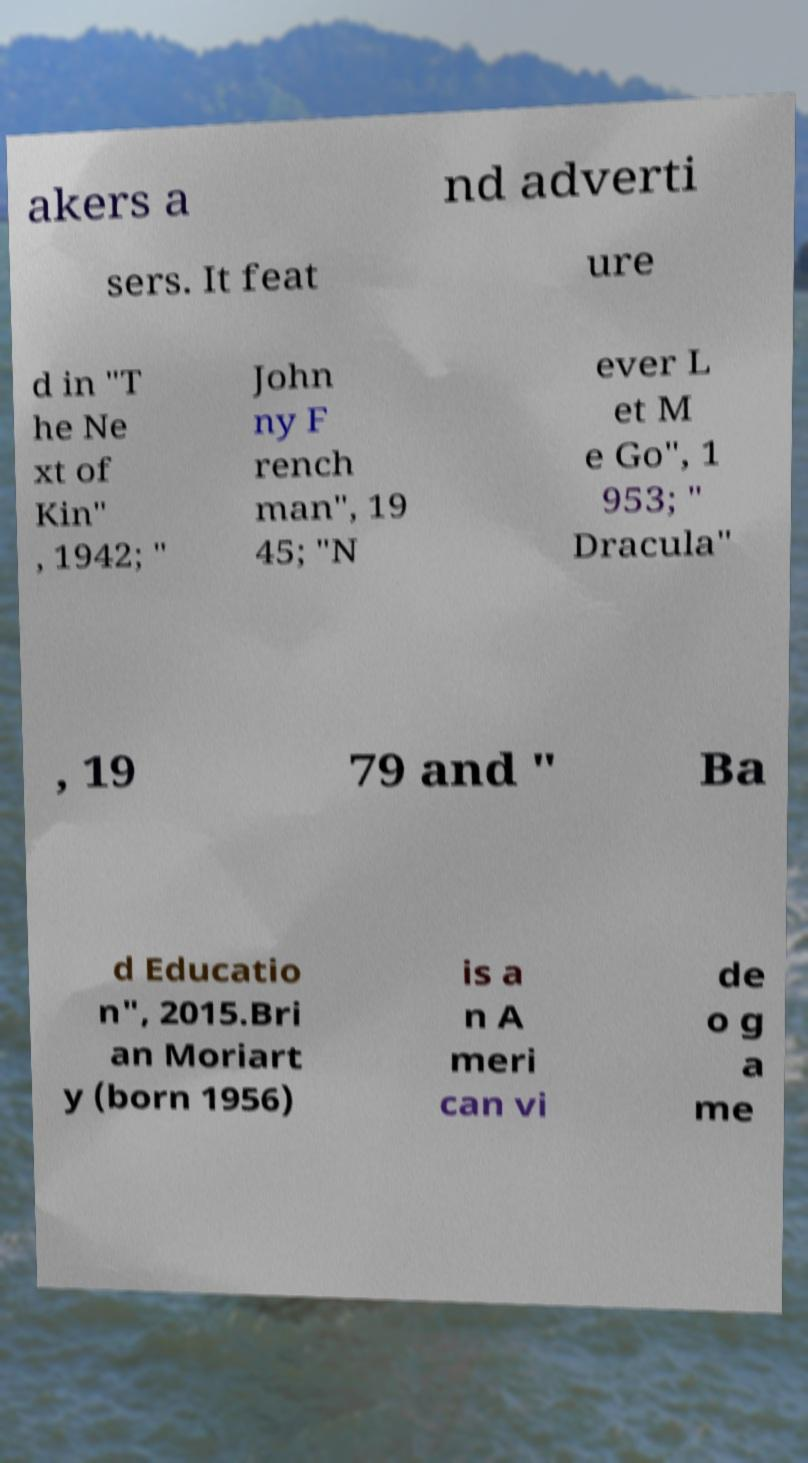There's text embedded in this image that I need extracted. Can you transcribe it verbatim? akers a nd adverti sers. It feat ure d in "T he Ne xt of Kin" , 1942; " John ny F rench man", 19 45; "N ever L et M e Go", 1 953; " Dracula" , 19 79 and " Ba d Educatio n", 2015.Bri an Moriart y (born 1956) is a n A meri can vi de o g a me 